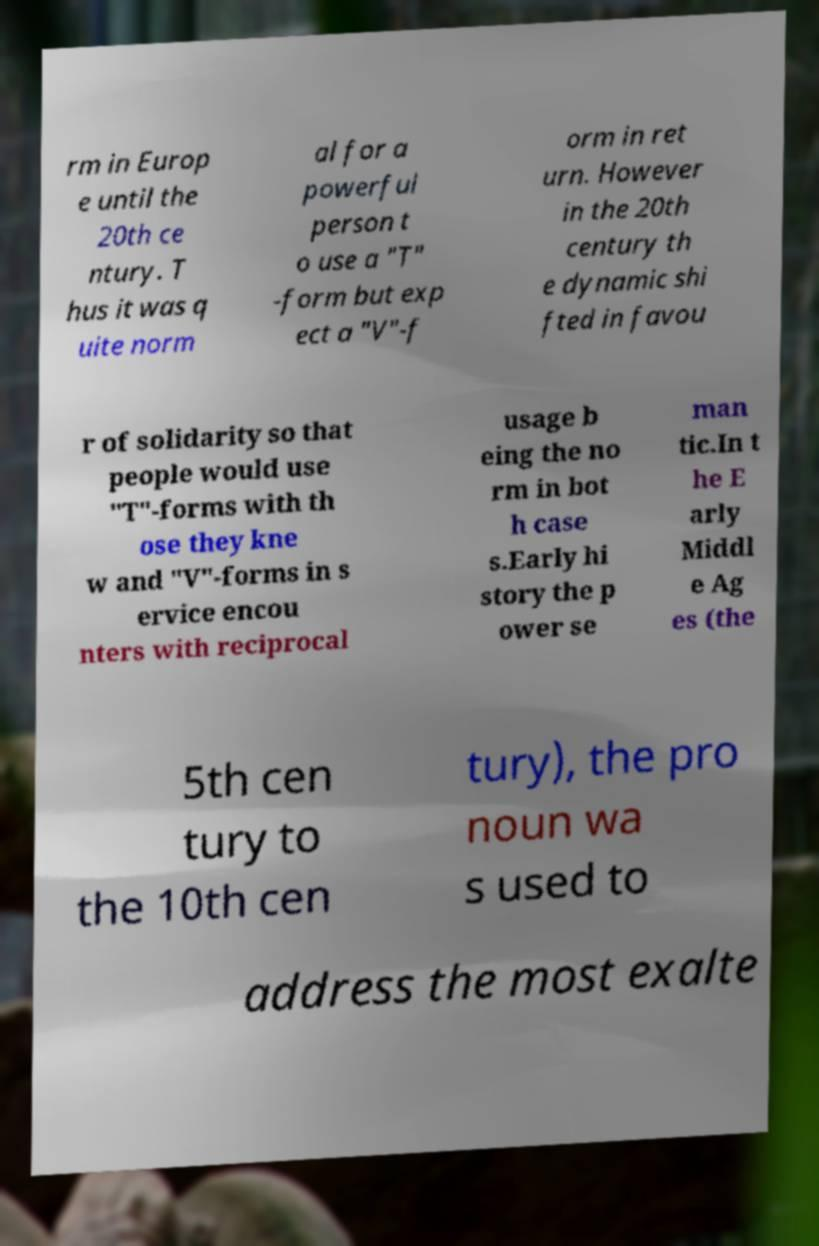Please identify and transcribe the text found in this image. rm in Europ e until the 20th ce ntury. T hus it was q uite norm al for a powerful person t o use a "T" -form but exp ect a "V"-f orm in ret urn. However in the 20th century th e dynamic shi fted in favou r of solidarity so that people would use "T"-forms with th ose they kne w and "V"-forms in s ervice encou nters with reciprocal usage b eing the no rm in bot h case s.Early hi story the p ower se man tic.In t he E arly Middl e Ag es (the 5th cen tury to the 10th cen tury), the pro noun wa s used to address the most exalte 